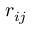<formula> <loc_0><loc_0><loc_500><loc_500>r _ { i j }</formula> 